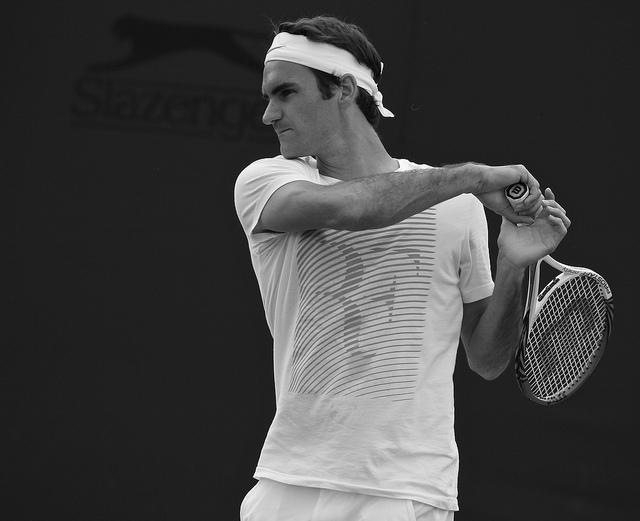How many people are shown?
Give a very brief answer. 1. How many people are in the picture?
Give a very brief answer. 1. How many chairs are there?
Give a very brief answer. 0. 